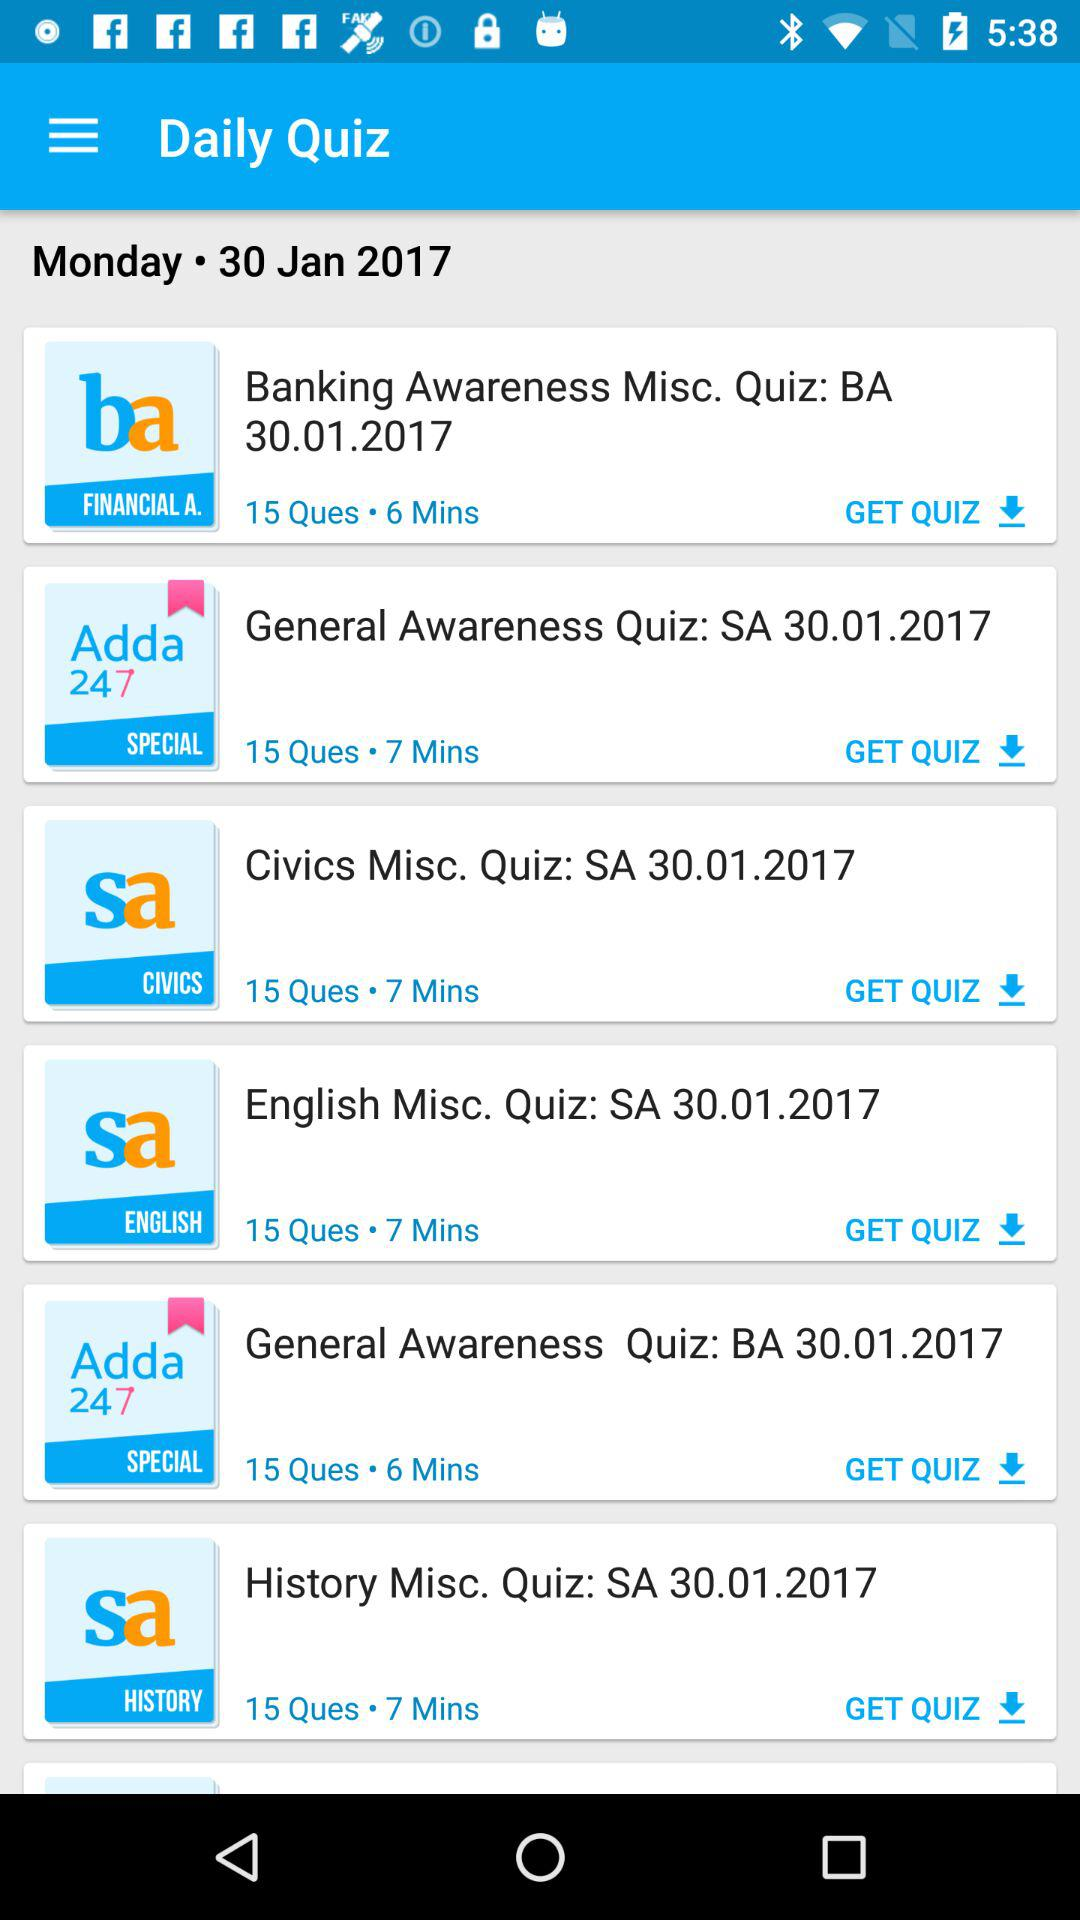What are the different types of daily quizzes? The different types of daily quizzes are "Banking Awareness Misc. Quiz: BA 30.01.2017", "General Awareness Quiz: SA 30.01.2017", "Civics Misc. Quiz: SA 30.01.2017", "English Misc. Quiz: SA 30.01.2017", "General Awareness Quiz: BA 30.01.2017" and "History Misc. Quiz: SA 30.01.2017". 